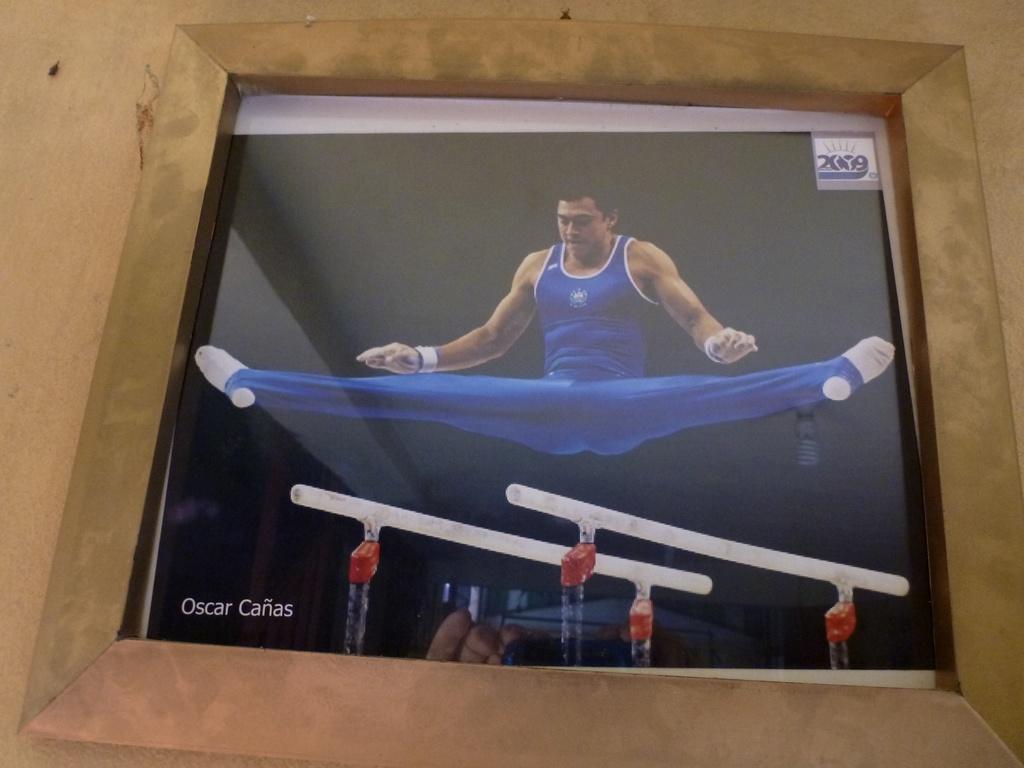What is the name of the gymnast?
Your response must be concise. Oscar canas. What name is in the bottom corner of the photo?
Offer a very short reply. Oscar canas. 